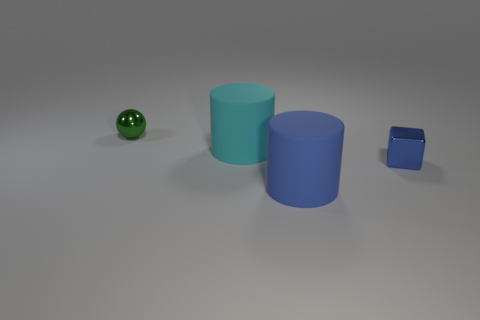Do the matte cylinder that is in front of the big cyan rubber cylinder and the rubber thing that is behind the tiny blue object have the same size?
Your answer should be very brief. Yes. What number of tiny things are either cyan objects or blue cylinders?
Ensure brevity in your answer.  0. How many objects are in front of the tiny green thing and to the left of the tiny cube?
Make the answer very short. 2. Does the small block have the same material as the small thing that is to the left of the blue metallic block?
Offer a very short reply. Yes. How many cyan things are either small metallic objects or large things?
Provide a short and direct response. 1. Is there another blue block that has the same size as the blue metal cube?
Give a very brief answer. No. What material is the big cylinder in front of the cylinder that is on the left side of the big rubber object that is in front of the large cyan cylinder?
Provide a short and direct response. Rubber. Are there an equal number of big cyan cylinders behind the small blue shiny thing and rubber things?
Make the answer very short. No. Does the big thing that is to the right of the large cyan object have the same material as the block in front of the cyan cylinder?
Offer a very short reply. No. How many objects are large cyan cylinders or large matte cylinders that are behind the cube?
Ensure brevity in your answer.  1. 